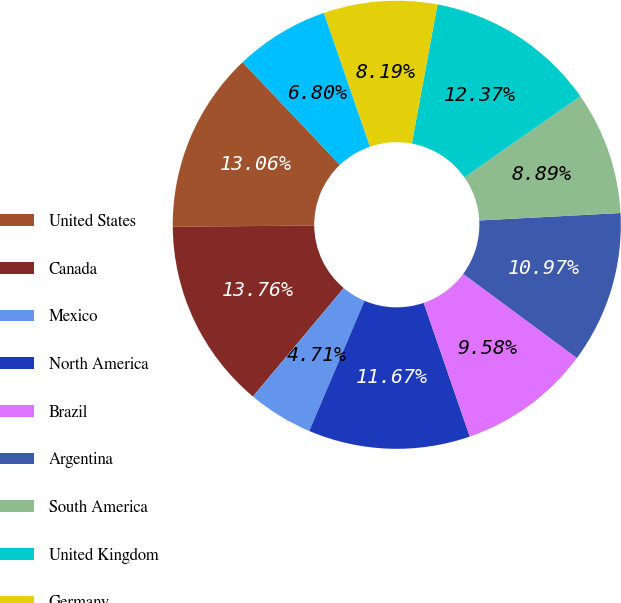Convert chart. <chart><loc_0><loc_0><loc_500><loc_500><pie_chart><fcel>United States<fcel>Canada<fcel>Mexico<fcel>North America<fcel>Brazil<fcel>Argentina<fcel>South America<fcel>United Kingdom<fcel>Germany<fcel>EU21 (d)<nl><fcel>13.06%<fcel>13.76%<fcel>4.71%<fcel>11.67%<fcel>9.58%<fcel>10.97%<fcel>8.89%<fcel>12.37%<fcel>8.19%<fcel>6.8%<nl></chart> 